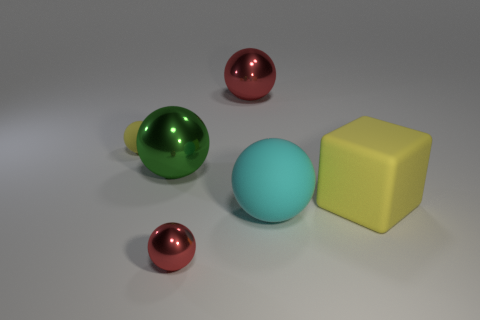Subtract all yellow matte spheres. How many spheres are left? 4 Subtract all blue spheres. Subtract all green cylinders. How many spheres are left? 5 Add 4 large spheres. How many objects exist? 10 Subtract all spheres. How many objects are left? 1 Add 3 large green balls. How many large green balls are left? 4 Add 5 brown things. How many brown things exist? 5 Subtract 0 yellow cylinders. How many objects are left? 6 Subtract all large spheres. Subtract all cyan metal cubes. How many objects are left? 3 